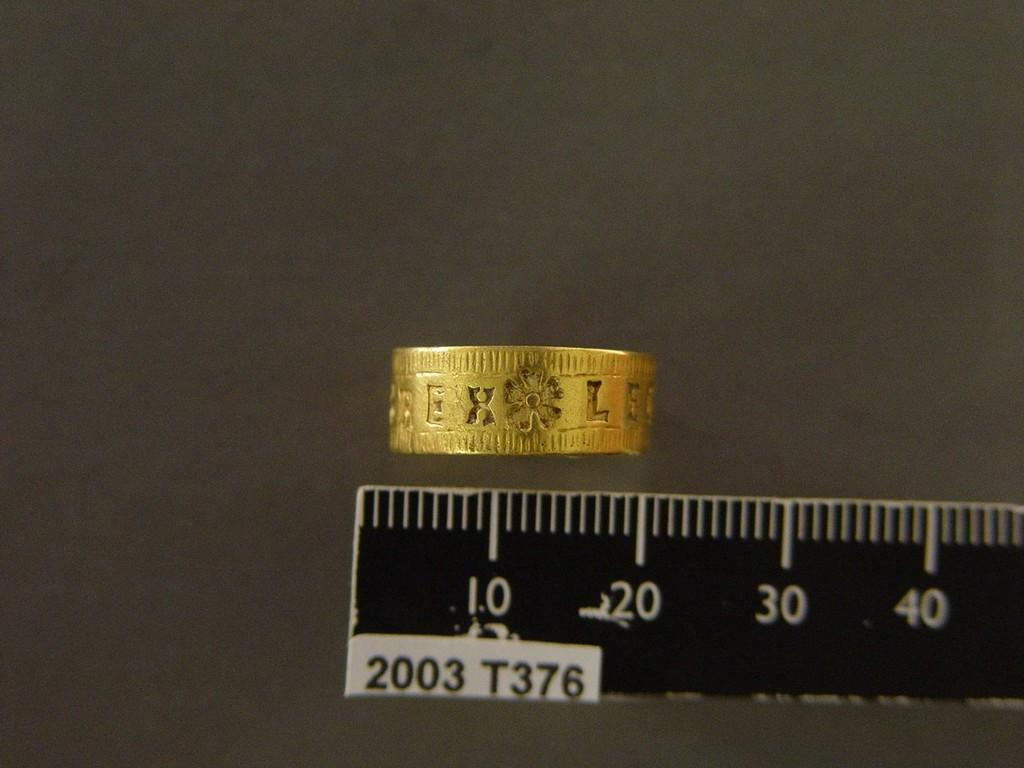Provide a one-sentence caption for the provided image. A gold ring with the letters EXLE engraved on it is being measured. 